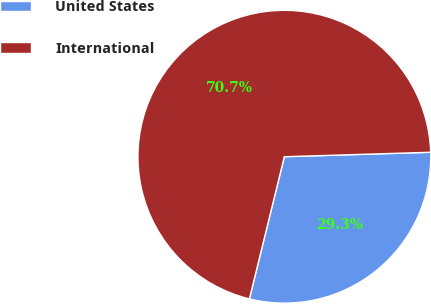Convert chart to OTSL. <chart><loc_0><loc_0><loc_500><loc_500><pie_chart><fcel>United States<fcel>International<nl><fcel>29.32%<fcel>70.68%<nl></chart> 